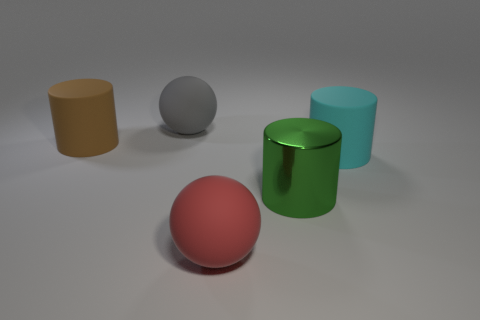Add 5 big green shiny things. How many objects exist? 10 Subtract all cylinders. How many objects are left? 2 Subtract all rubber cylinders. Subtract all red things. How many objects are left? 2 Add 2 big matte spheres. How many big matte spheres are left? 4 Add 1 metallic cylinders. How many metallic cylinders exist? 2 Subtract 1 cyan cylinders. How many objects are left? 4 